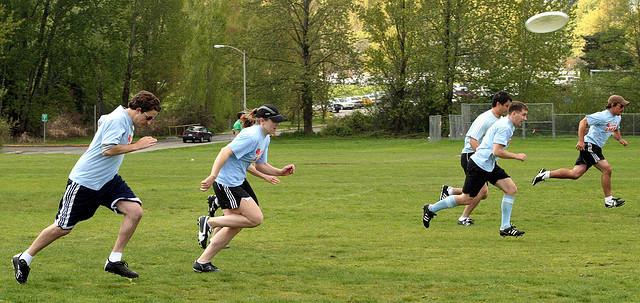Are all the players the same gender?
Write a very short answer. No. Are these joggers?
Give a very brief answer. No. Are the people walking?
Short answer required. No. 